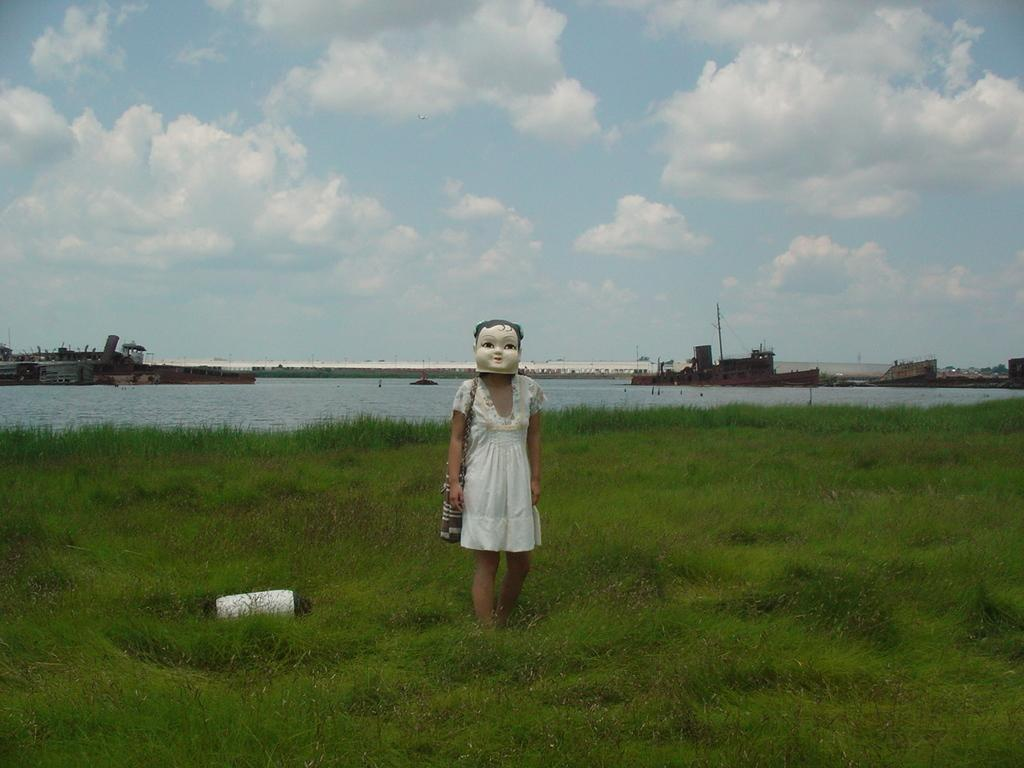Who is present in the image? There is a woman in the image. What is the woman wearing? The woman is wearing a board. Where is the woman standing? The woman is standing in the grass. What can be seen in the background of the image? There are ships visible in the water behind the woman. What type of stream can be seen flowing through the woman's hair in the image? There is no stream visible in the image, nor is there any indication that the woman's hair is wet or flowing. 